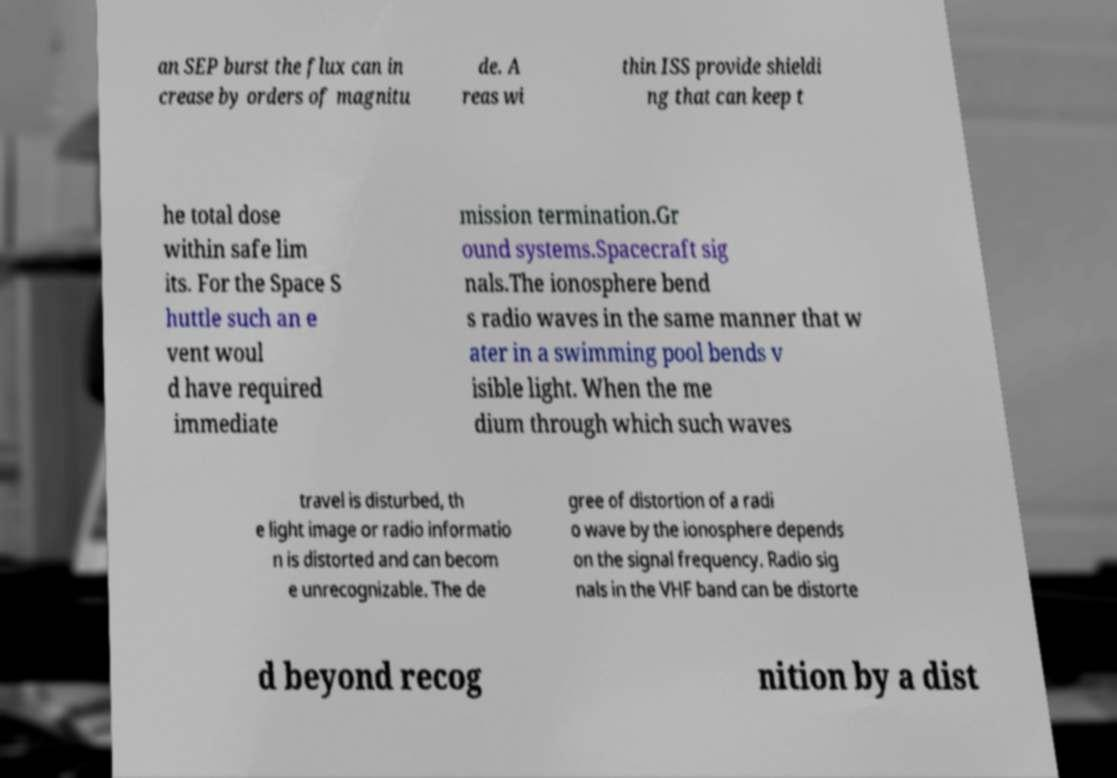There's text embedded in this image that I need extracted. Can you transcribe it verbatim? an SEP burst the flux can in crease by orders of magnitu de. A reas wi thin ISS provide shieldi ng that can keep t he total dose within safe lim its. For the Space S huttle such an e vent woul d have required immediate mission termination.Gr ound systems.Spacecraft sig nals.The ionosphere bend s radio waves in the same manner that w ater in a swimming pool bends v isible light. When the me dium through which such waves travel is disturbed, th e light image or radio informatio n is distorted and can becom e unrecognizable. The de gree of distortion of a radi o wave by the ionosphere depends on the signal frequency. Radio sig nals in the VHF band can be distorte d beyond recog nition by a dist 